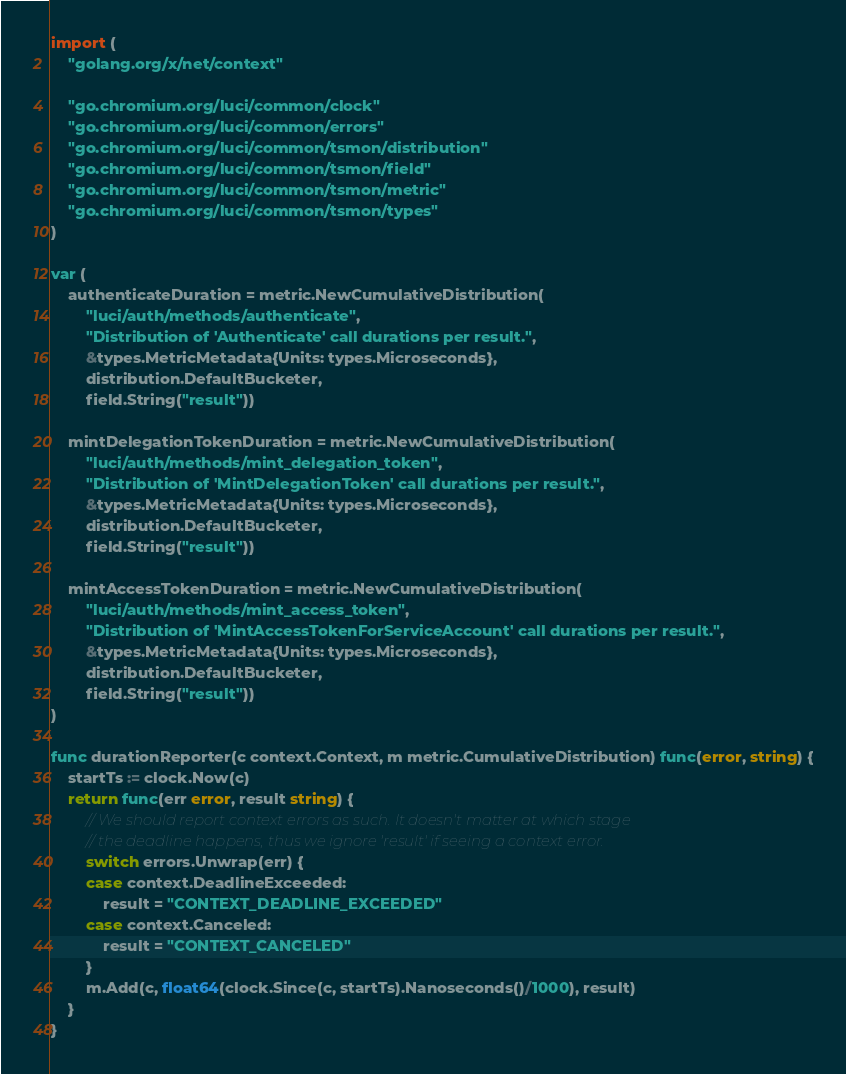Convert code to text. <code><loc_0><loc_0><loc_500><loc_500><_Go_>
import (
	"golang.org/x/net/context"

	"go.chromium.org/luci/common/clock"
	"go.chromium.org/luci/common/errors"
	"go.chromium.org/luci/common/tsmon/distribution"
	"go.chromium.org/luci/common/tsmon/field"
	"go.chromium.org/luci/common/tsmon/metric"
	"go.chromium.org/luci/common/tsmon/types"
)

var (
	authenticateDuration = metric.NewCumulativeDistribution(
		"luci/auth/methods/authenticate",
		"Distribution of 'Authenticate' call durations per result.",
		&types.MetricMetadata{Units: types.Microseconds},
		distribution.DefaultBucketer,
		field.String("result"))

	mintDelegationTokenDuration = metric.NewCumulativeDistribution(
		"luci/auth/methods/mint_delegation_token",
		"Distribution of 'MintDelegationToken' call durations per result.",
		&types.MetricMetadata{Units: types.Microseconds},
		distribution.DefaultBucketer,
		field.String("result"))

	mintAccessTokenDuration = metric.NewCumulativeDistribution(
		"luci/auth/methods/mint_access_token",
		"Distribution of 'MintAccessTokenForServiceAccount' call durations per result.",
		&types.MetricMetadata{Units: types.Microseconds},
		distribution.DefaultBucketer,
		field.String("result"))
)

func durationReporter(c context.Context, m metric.CumulativeDistribution) func(error, string) {
	startTs := clock.Now(c)
	return func(err error, result string) {
		// We should report context errors as such. It doesn't matter at which stage
		// the deadline happens, thus we ignore 'result' if seeing a context error.
		switch errors.Unwrap(err) {
		case context.DeadlineExceeded:
			result = "CONTEXT_DEADLINE_EXCEEDED"
		case context.Canceled:
			result = "CONTEXT_CANCELED"
		}
		m.Add(c, float64(clock.Since(c, startTs).Nanoseconds()/1000), result)
	}
}
</code> 